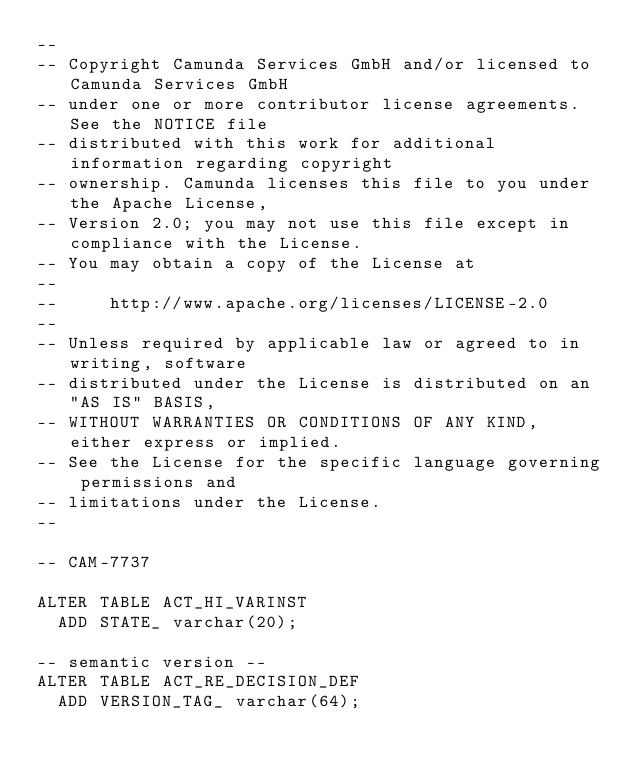Convert code to text. <code><loc_0><loc_0><loc_500><loc_500><_SQL_>--
-- Copyright Camunda Services GmbH and/or licensed to Camunda Services GmbH
-- under one or more contributor license agreements. See the NOTICE file
-- distributed with this work for additional information regarding copyright
-- ownership. Camunda licenses this file to you under the Apache License,
-- Version 2.0; you may not use this file except in compliance with the License.
-- You may obtain a copy of the License at
--
--     http://www.apache.org/licenses/LICENSE-2.0
--
-- Unless required by applicable law or agreed to in writing, software
-- distributed under the License is distributed on an "AS IS" BASIS,
-- WITHOUT WARRANTIES OR CONDITIONS OF ANY KIND, either express or implied.
-- See the License for the specific language governing permissions and
-- limitations under the License.
--

-- CAM-7737

ALTER TABLE ACT_HI_VARINST
  ADD STATE_ varchar(20);

-- semantic version --
ALTER TABLE ACT_RE_DECISION_DEF
  ADD VERSION_TAG_ varchar(64);
</code> 